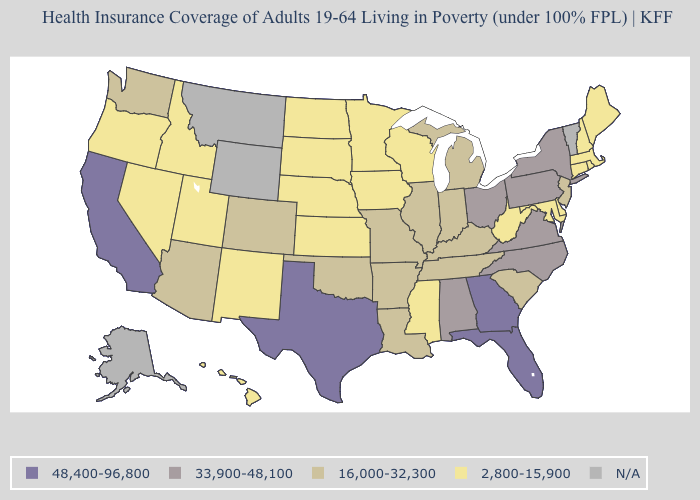What is the value of Arkansas?
Quick response, please. 16,000-32,300. Among the states that border Iowa , which have the highest value?
Answer briefly. Illinois, Missouri. What is the value of New Hampshire?
Give a very brief answer. 2,800-15,900. Name the states that have a value in the range N/A?
Concise answer only. Alaska, Montana, Vermont, Wyoming. Name the states that have a value in the range 33,900-48,100?
Give a very brief answer. Alabama, New York, North Carolina, Ohio, Pennsylvania, Virginia. Name the states that have a value in the range N/A?
Short answer required. Alaska, Montana, Vermont, Wyoming. Is the legend a continuous bar?
Keep it brief. No. Name the states that have a value in the range 2,800-15,900?
Give a very brief answer. Connecticut, Delaware, Hawaii, Idaho, Iowa, Kansas, Maine, Maryland, Massachusetts, Minnesota, Mississippi, Nebraska, Nevada, New Hampshire, New Mexico, North Dakota, Oregon, Rhode Island, South Dakota, Utah, West Virginia, Wisconsin. Which states hav the highest value in the MidWest?
Be succinct. Ohio. What is the value of New Mexico?
Be succinct. 2,800-15,900. What is the value of Georgia?
Short answer required. 48,400-96,800. What is the value of Florida?
Short answer required. 48,400-96,800. What is the lowest value in the USA?
Be succinct. 2,800-15,900. Which states hav the highest value in the South?
Quick response, please. Florida, Georgia, Texas. 